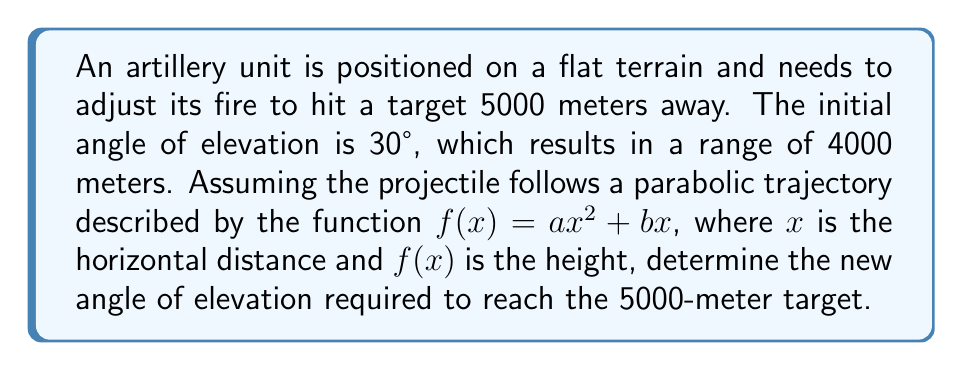Provide a solution to this math problem. To solve this problem, we'll use the principles of function transformations and trigonometry:

1) First, let's consider the original trajectory:
   $f(x) = ax^2 + bx$
   At $x = 4000$, $f(x) = 0$ (projectile hits the ground)
   At $x = 0$, angle of elevation is 30°

2) The angle of elevation is related to the derivative of $f(x)$ at $x = 0$:
   $f'(x) = 2ax + b$
   $\tan(30°) = f'(0) = b$
   $b = \tan(30°) = \frac{1}{\sqrt{3}}$

3) Using the fact that $f(4000) = 0$:
   $0 = a(4000)^2 + b(4000)$
   $0 = 16,000,000a + 4000(\frac{1}{\sqrt{3}})$
   $a = -\frac{1}{4000\sqrt{3}}$

4) Now we have the original function:
   $f(x) = -\frac{1}{4000\sqrt{3}}x^2 + \frac{1}{\sqrt{3}}x$

5) To reach 5000 meters, we need to scale the function horizontally by a factor of $\frac{5000}{4000} = \frac{5}{4}$:
   $g(x) = f(\frac{4}{5}x) = -\frac{1}{4000\sqrt{3}}(\frac{4}{5}x)^2 + \frac{1}{\sqrt{3}}(\frac{4}{5}x)$
   $g(x) = -\frac{16}{25000\sqrt{3}}x^2 + \frac{4}{5\sqrt{3}}x$

6) The new angle of elevation is given by $g'(0)$:
   $g'(x) = -\frac{32}{25000\sqrt{3}}x + \frac{4}{5\sqrt{3}}$
   $g'(0) = \frac{4}{5\sqrt{3}}$

7) The new angle $\theta$ is:
   $\tan(\theta) = \frac{4}{5\sqrt{3}}$
   $\theta = \arctan(\frac{4}{5\sqrt{3}}) \approx 24.44°$
Answer: The new angle of elevation required to reach the 5000-meter target is approximately 24.44°. 